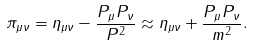Convert formula to latex. <formula><loc_0><loc_0><loc_500><loc_500>\pi _ { \mu \nu } = \eta _ { \mu \nu } - \frac { P _ { \mu } P _ { \nu } } { P ^ { 2 } } \approx \eta _ { \mu \nu } + \frac { P _ { \mu } P _ { \nu } } { m ^ { 2 } } .</formula> 